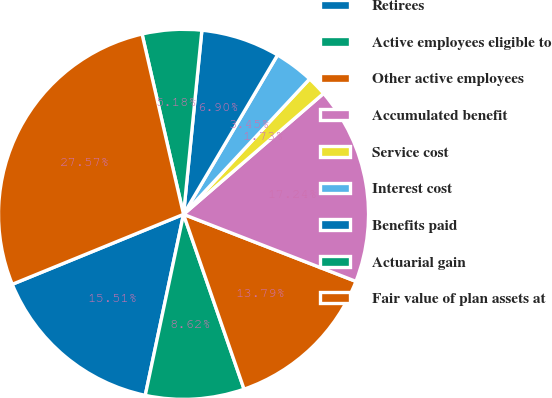Convert chart to OTSL. <chart><loc_0><loc_0><loc_500><loc_500><pie_chart><fcel>Retirees<fcel>Active employees eligible to<fcel>Other active employees<fcel>Accumulated benefit<fcel>Service cost<fcel>Interest cost<fcel>Benefits paid<fcel>Actuarial gain<fcel>Fair value of plan assets at<nl><fcel>15.51%<fcel>8.62%<fcel>13.79%<fcel>17.24%<fcel>1.73%<fcel>3.45%<fcel>6.9%<fcel>5.18%<fcel>27.57%<nl></chart> 